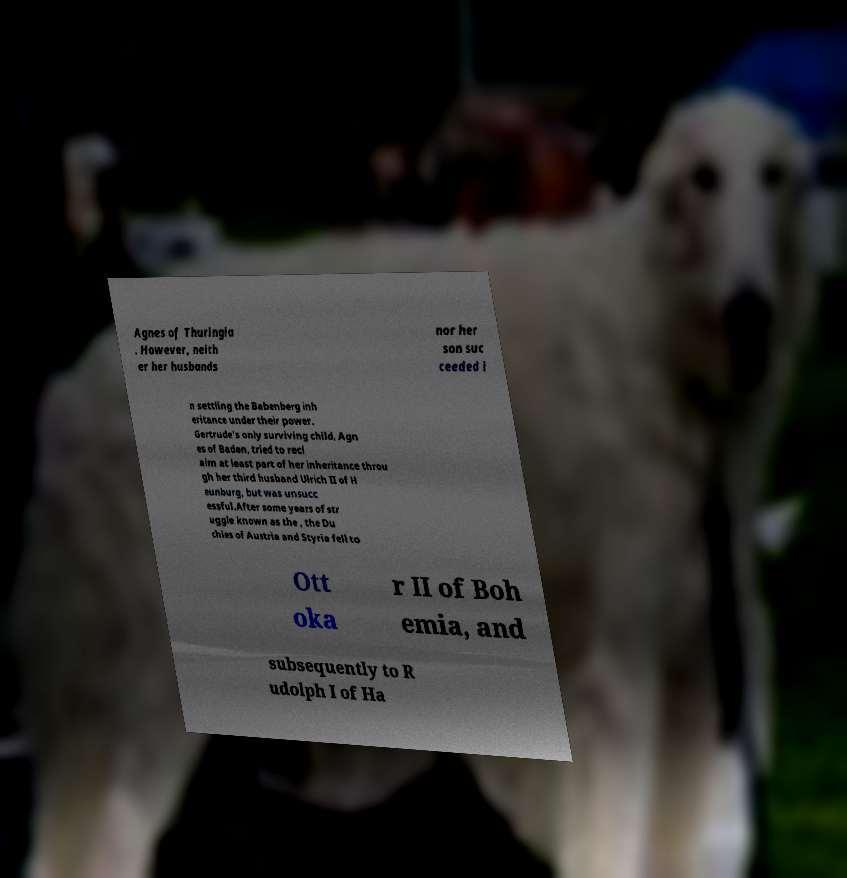I need the written content from this picture converted into text. Can you do that? Agnes of Thuringia . However, neith er her husbands nor her son suc ceeded i n settling the Babenberg inh eritance under their power. Gertrude's only surviving child, Agn es of Baden, tried to recl aim at least part of her inheritance throu gh her third husband Ulrich II of H eunburg, but was unsucc essful.After some years of str uggle known as the , the Du chies of Austria and Styria fell to Ott oka r II of Boh emia, and subsequently to R udolph I of Ha 